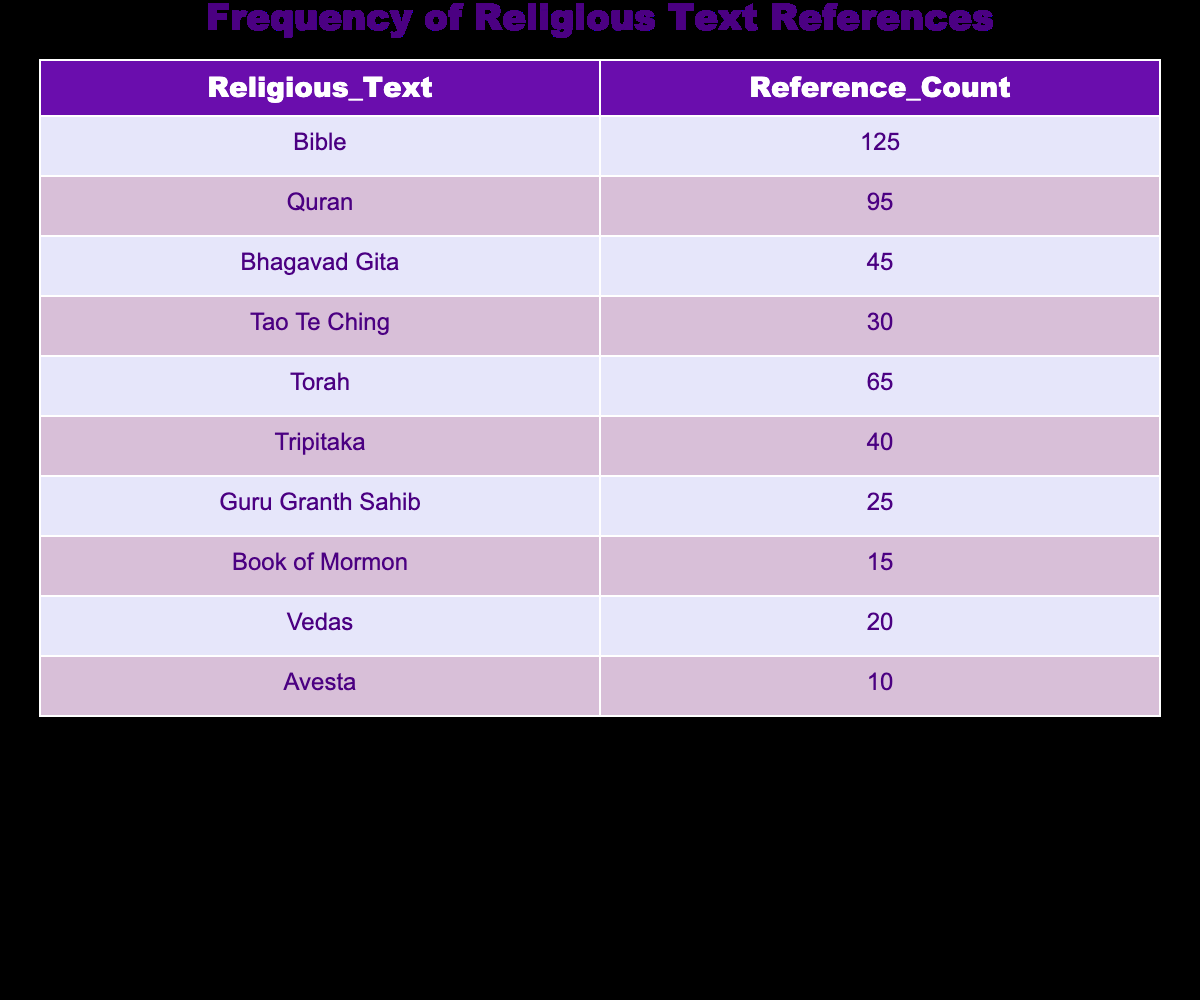What is the reference count for the Bhagavad Gita? According to the table, the Bhagavad Gita has a reference count of 45.
Answer: 45 Which religious text has the highest number of references? The Bible has the highest number of references, with a total of 125, as indicated in the first row of the table.
Answer: Bible How many more references does the Quran have than the Guru Granth Sahib? The Quran has 95 references, while the Guru Granth Sahib has 25. The difference is 95 - 25 = 70.
Answer: 70 What is the total number of references for the Torah and the Tripitaka combined? The Torah has 65 references and the Tripitaka has 40. Adding these amounts together gives 65 + 40 = 105.
Answer: 105 Is it true that the Avesta has more references than the Book of Mormon? The Avesta has 10 references, and the Book of Mormon has 15 references. Since 10 is not greater than 15, this statement is false.
Answer: No Which two religious texts have reference counts that are closest to each other? By examining the reference counts, the Tao Te Ching (30) and Tripitaka (40) are the closest. The difference is 40 - 30 = 10.
Answer: Tao Te Ching and Tripitaka What is the average reference count of the top three religious texts? The top three religious texts are the Bible (125), Quran (95), and Torah (65). Their sum is 125 + 95 + 65 = 285. Dividing by 3 gives an average of 285 / 3 = 95.
Answer: 95 How many religious texts have more than 50 references? The texts with more than 50 references are the Bible (125), Quran (95), and Torah (65). This makes three texts in total.
Answer: 3 What is the total number of references for all listed religious texts? To find the total, sum all counts: 125 + 95 + 45 + 30 + 65 + 40 + 25 + 15 + 20 + 10 =  470.
Answer: 470 